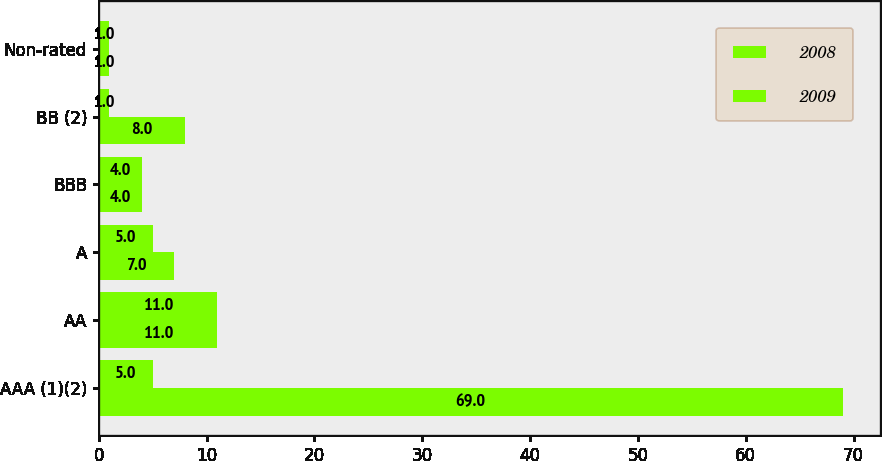Convert chart to OTSL. <chart><loc_0><loc_0><loc_500><loc_500><stacked_bar_chart><ecel><fcel>AAA (1)(2)<fcel>AA<fcel>A<fcel>BBB<fcel>BB (2)<fcel>Non-rated<nl><fcel>2008<fcel>69<fcel>11<fcel>7<fcel>4<fcel>8<fcel>1<nl><fcel>2009<fcel>5<fcel>11<fcel>5<fcel>4<fcel>1<fcel>1<nl></chart> 